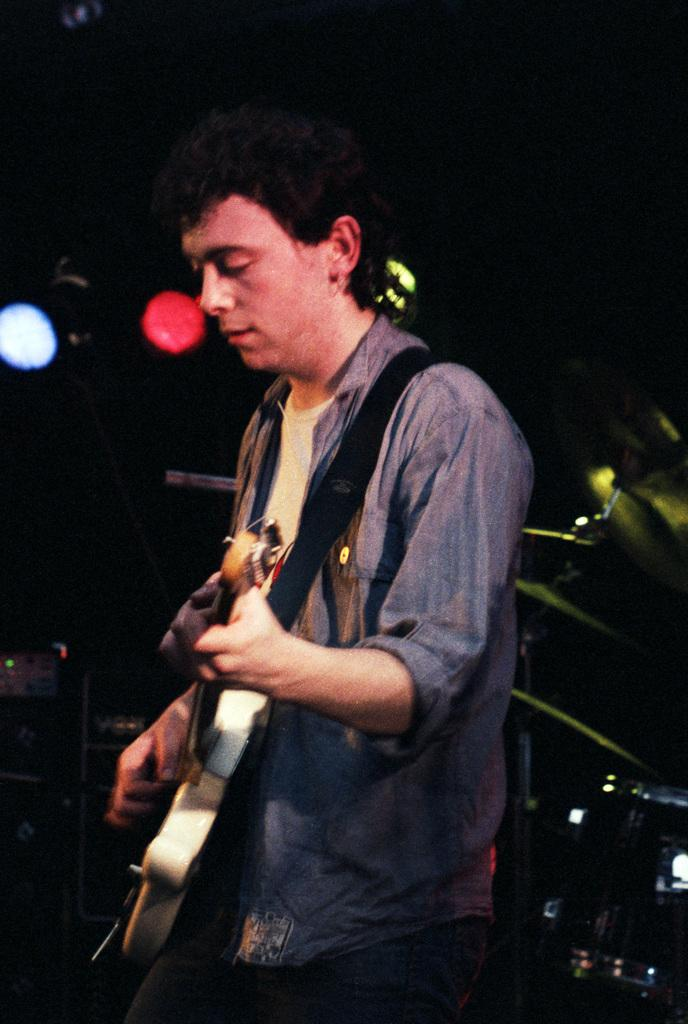What is the man in the image doing? The man is playing a guitar in the image. What type of clothing is the man wearing? The man is wearing a shirt, trousers, and a t-shirt. What can be seen in the background of the image? There are lights visible in the background of the image. Can you see any wounds on the man's body in the image? There is no indication of any wounds on the man's body in the image. What type of sponge is the man using to play the guitar? There is no sponge present in the image, and the man is using his hands to play the guitar. 